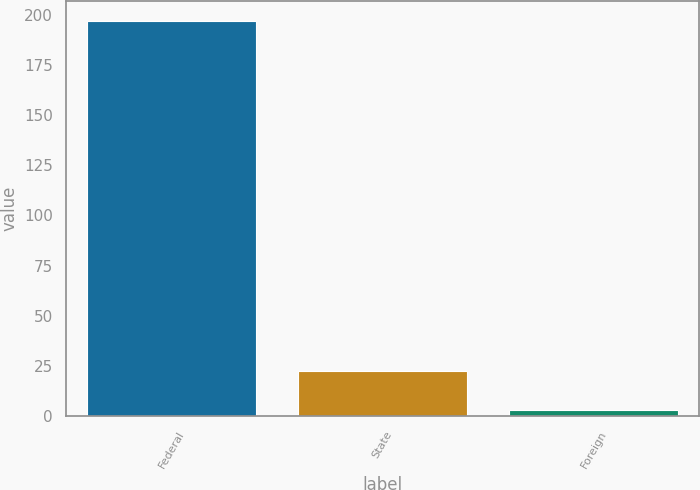Convert chart. <chart><loc_0><loc_0><loc_500><loc_500><bar_chart><fcel>Federal<fcel>State<fcel>Foreign<nl><fcel>197<fcel>22.4<fcel>3<nl></chart> 